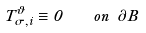<formula> <loc_0><loc_0><loc_500><loc_500>T _ { \sigma , i } ^ { \vartheta } \equiv 0 \quad o n \ \partial B</formula> 